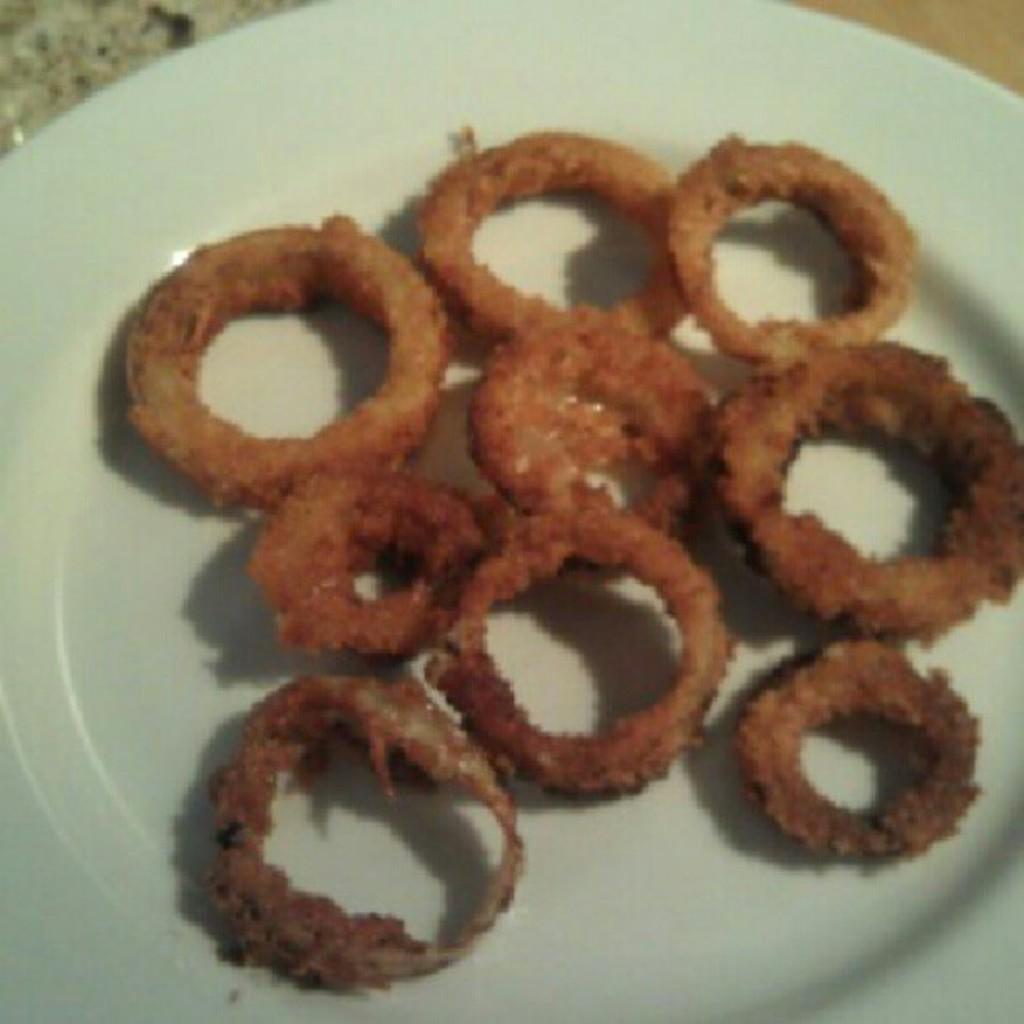Please provide a concise description of this image. In this image I can see a white colour plate and on it I can see brown colour food. 